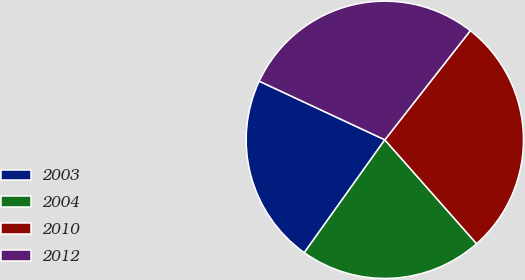<chart> <loc_0><loc_0><loc_500><loc_500><pie_chart><fcel>2003<fcel>2004<fcel>2010<fcel>2012<nl><fcel>22.09%<fcel>21.38%<fcel>27.91%<fcel>28.62%<nl></chart> 